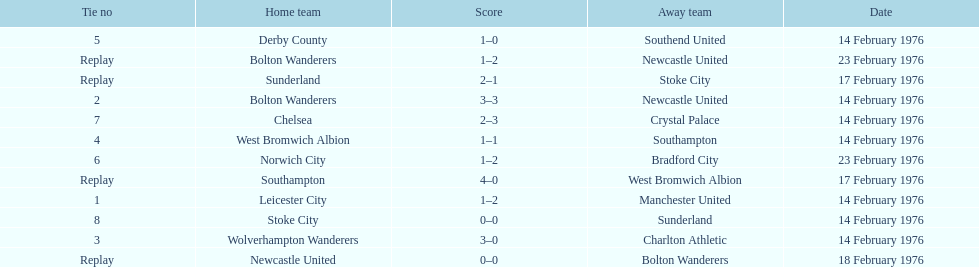Who had a better score, manchester united or wolverhampton wanderers? Wolverhampton Wanderers. 